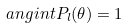Convert formula to latex. <formula><loc_0><loc_0><loc_500><loc_500>\ a n g i n t P _ { l } ( \theta ) = 1</formula> 